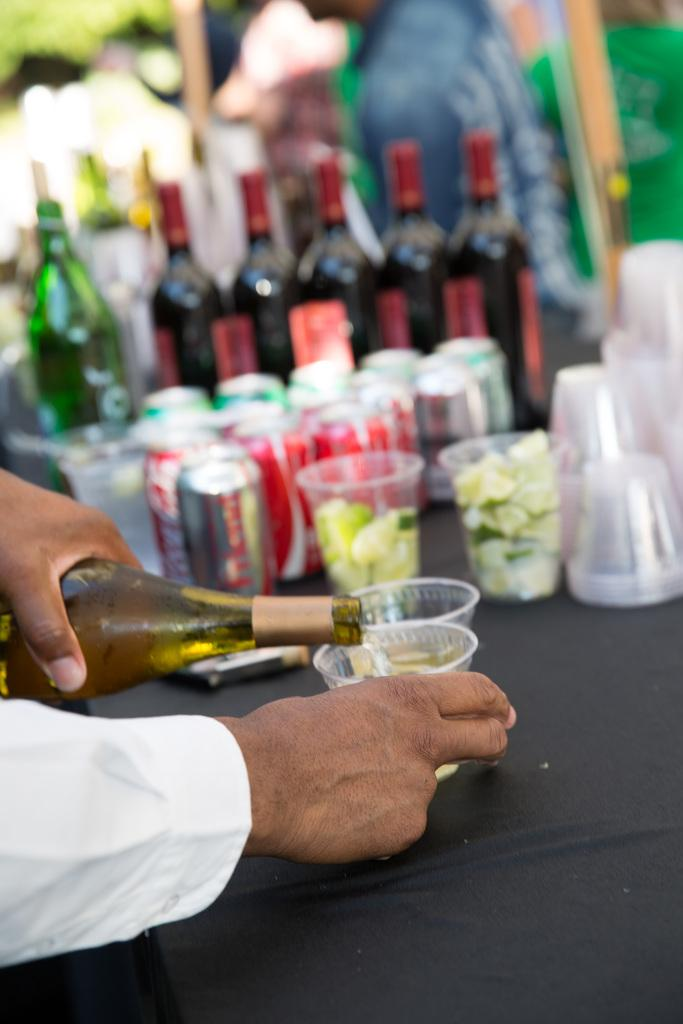<image>
Write a terse but informative summary of the picture. A man pouring some type of alcohol into a small cup with Coca-Cola and other drinks sitting on the table in the background. 